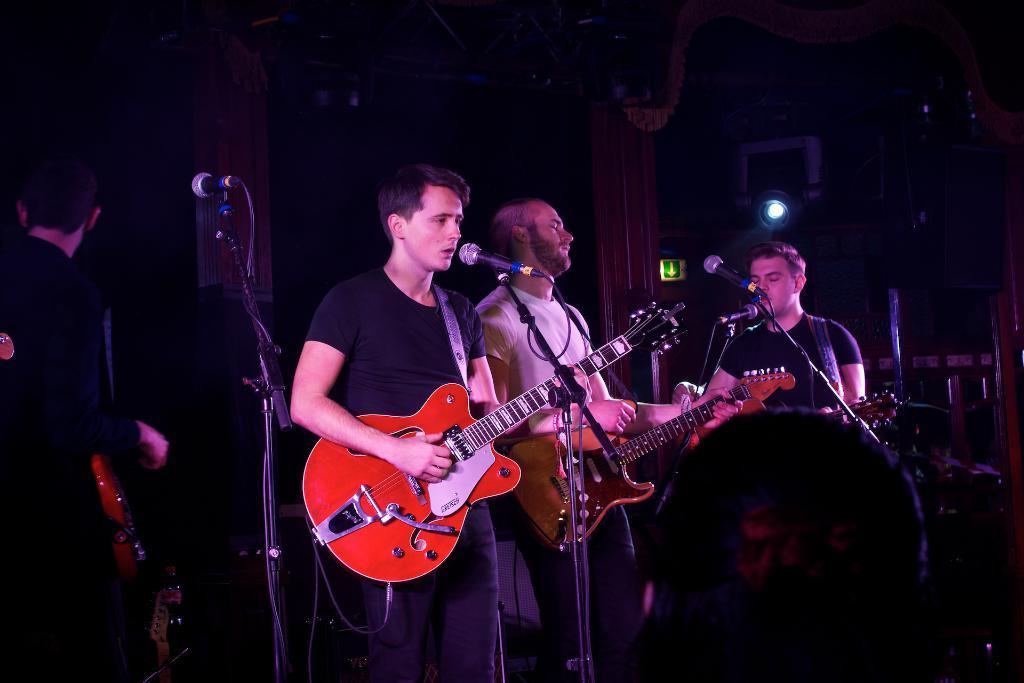Can you describe this image briefly? This picture shows few people standing and playing guitar and a man singing with the help of a microphone 